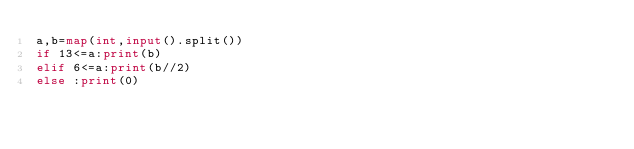<code> <loc_0><loc_0><loc_500><loc_500><_Python_>a,b=map(int,input().split())
if 13<=a:print(b)
elif 6<=a:print(b//2)
else :print(0)</code> 